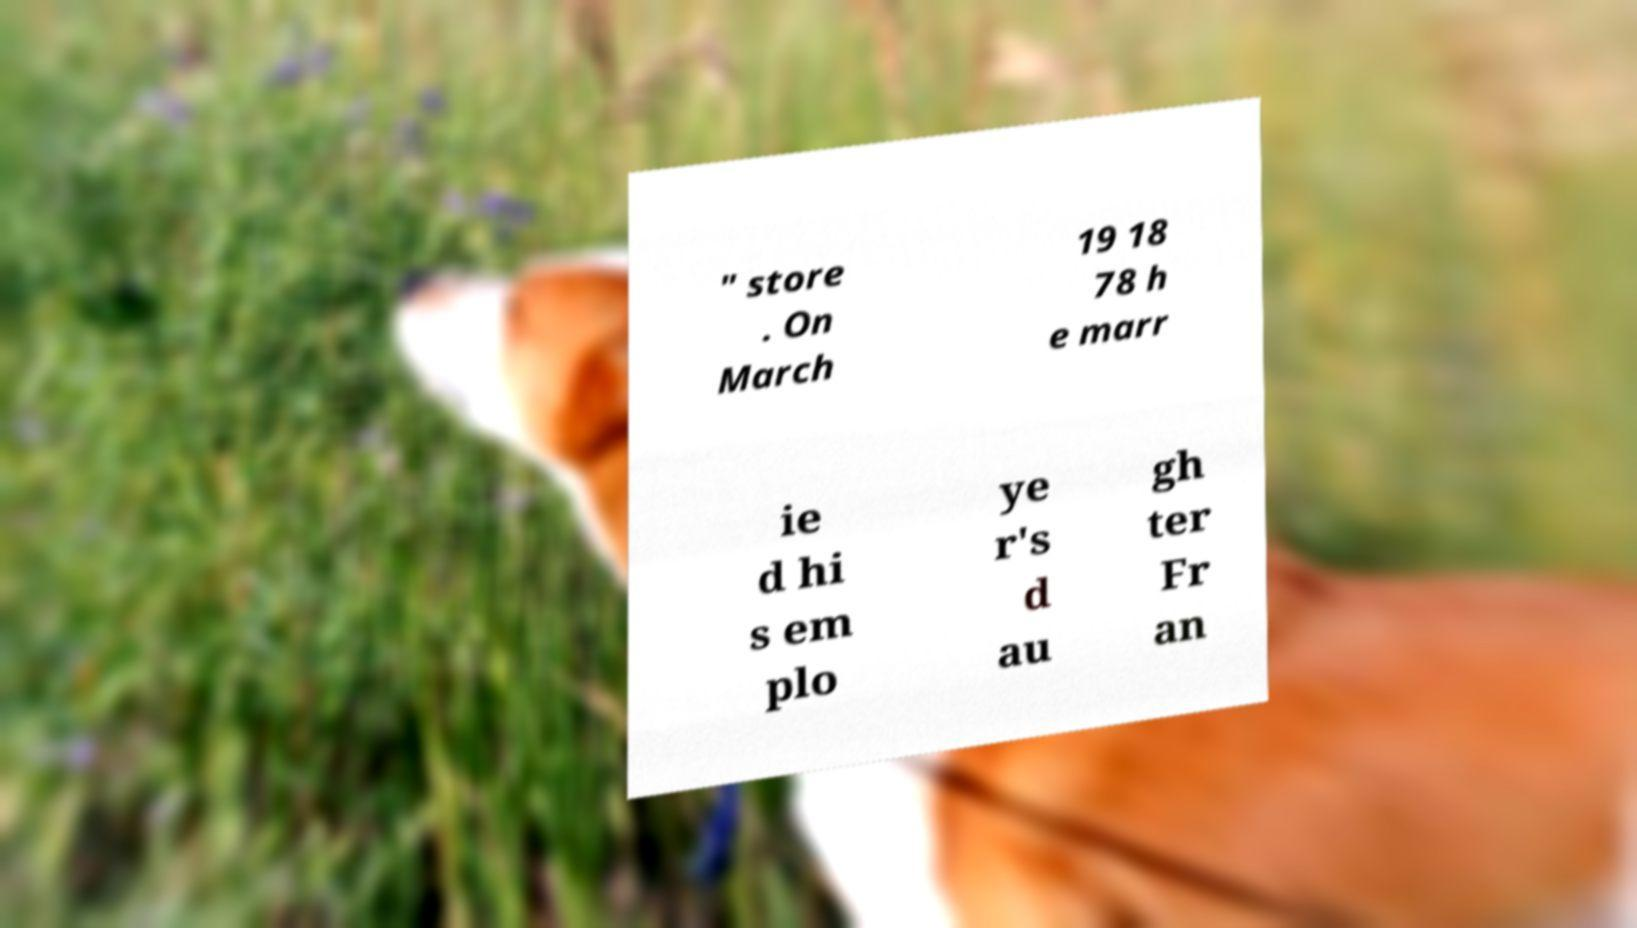For documentation purposes, I need the text within this image transcribed. Could you provide that? " store . On March 19 18 78 h e marr ie d hi s em plo ye r's d au gh ter Fr an 